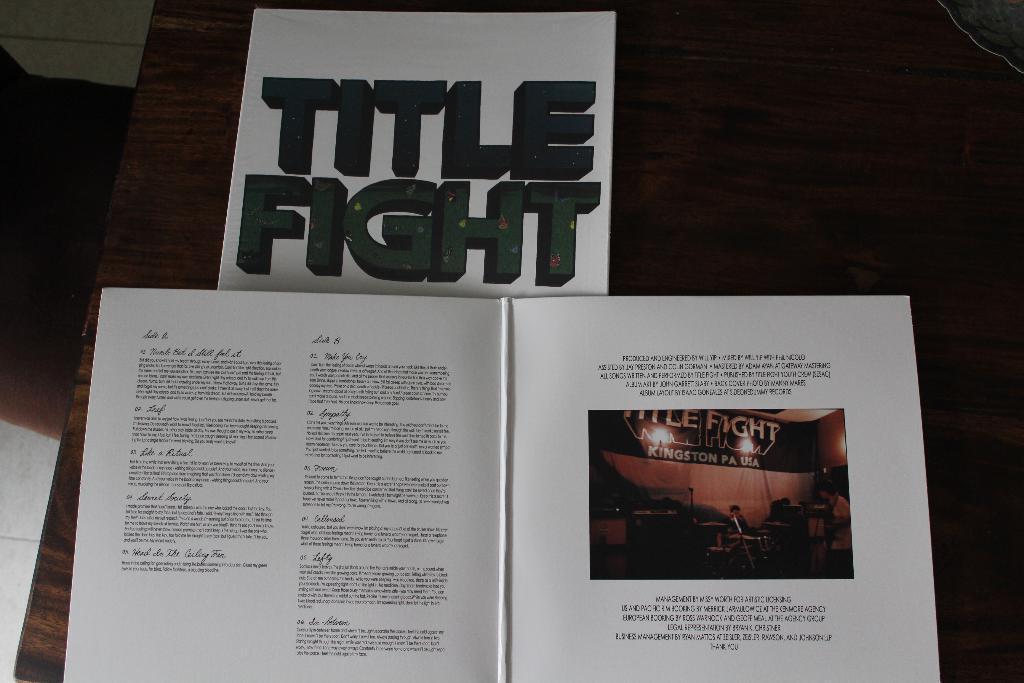Could you give a brief overview of what you see in this image? There is a wooden surface. On that there is a surface. On the book something is written. Also there is an image. And there is something written in the white background. On the image there is a banner, lights and few people. 